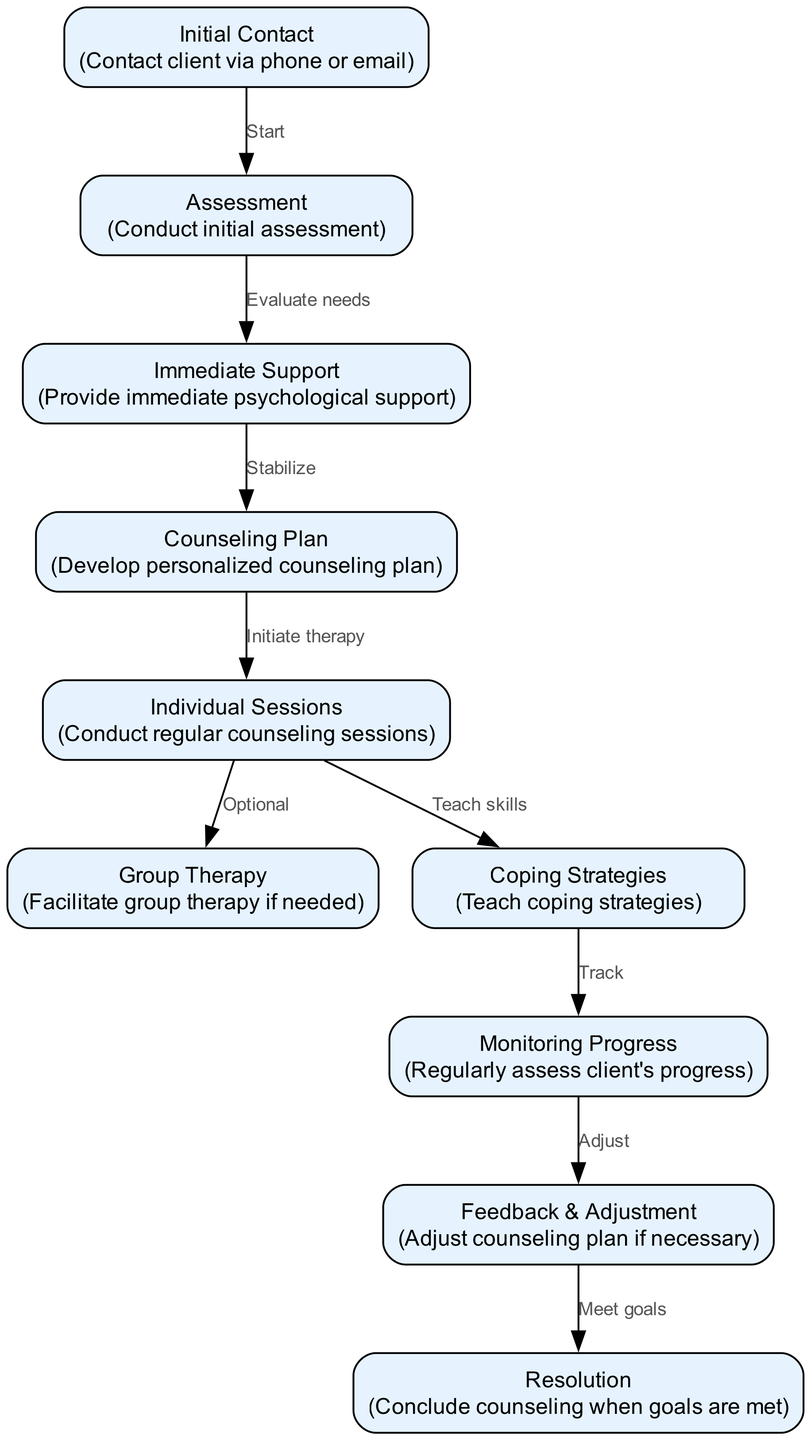What is the first step in the grief counseling process? The diagram indicates that the first step is "Initial Contact." This is represented as the starting node from which the flow of the process begins.
Answer: Initial Contact How many nodes are in the diagram? By counting each labeled step or element in the diagram, there are a total of ten nodes listed.
Answer: 10 What does the "Assessment" node lead to? According to the flowchart, the "Assessment" node leads to the "Immediate Support" node, as indicated by the directed edge connecting them.
Answer: Immediate Support What is provided in the "Immediate Support" node? The description of the "Immediate Support" node states that it is for providing "immediate psychological support," which highlights the purpose of this step.
Answer: Immediate psychological support Which two nodes can follow the "Individual Sessions" node? The flowchart shows that the "Individual Sessions" node can lead to either "Group Therapy" or "Coping Strategies," as both nodes are connected by directed edges from "Individual Sessions."
Answer: Group Therapy, Coping Strategies What is the final step in the counseling process? According to the diagram, the final step is labeled "Resolution," which signifies the conclusion of the counseling process once goals are met.
Answer: Resolution Which node involves teaching skills? The "Coping Strategies" node is specifically related to teaching skills, as indicated by the description and its connection stemming from the "Individual Sessions" node.
Answer: Coping Strategies How does the process adjust after monitoring progress? After the "Monitoring Progress" node, the process moves to the "Feedback & Adjustment" node, where adjustments to the counseling plan are made as necessary based on the client's developments.
Answer: Feedback & Adjustment 